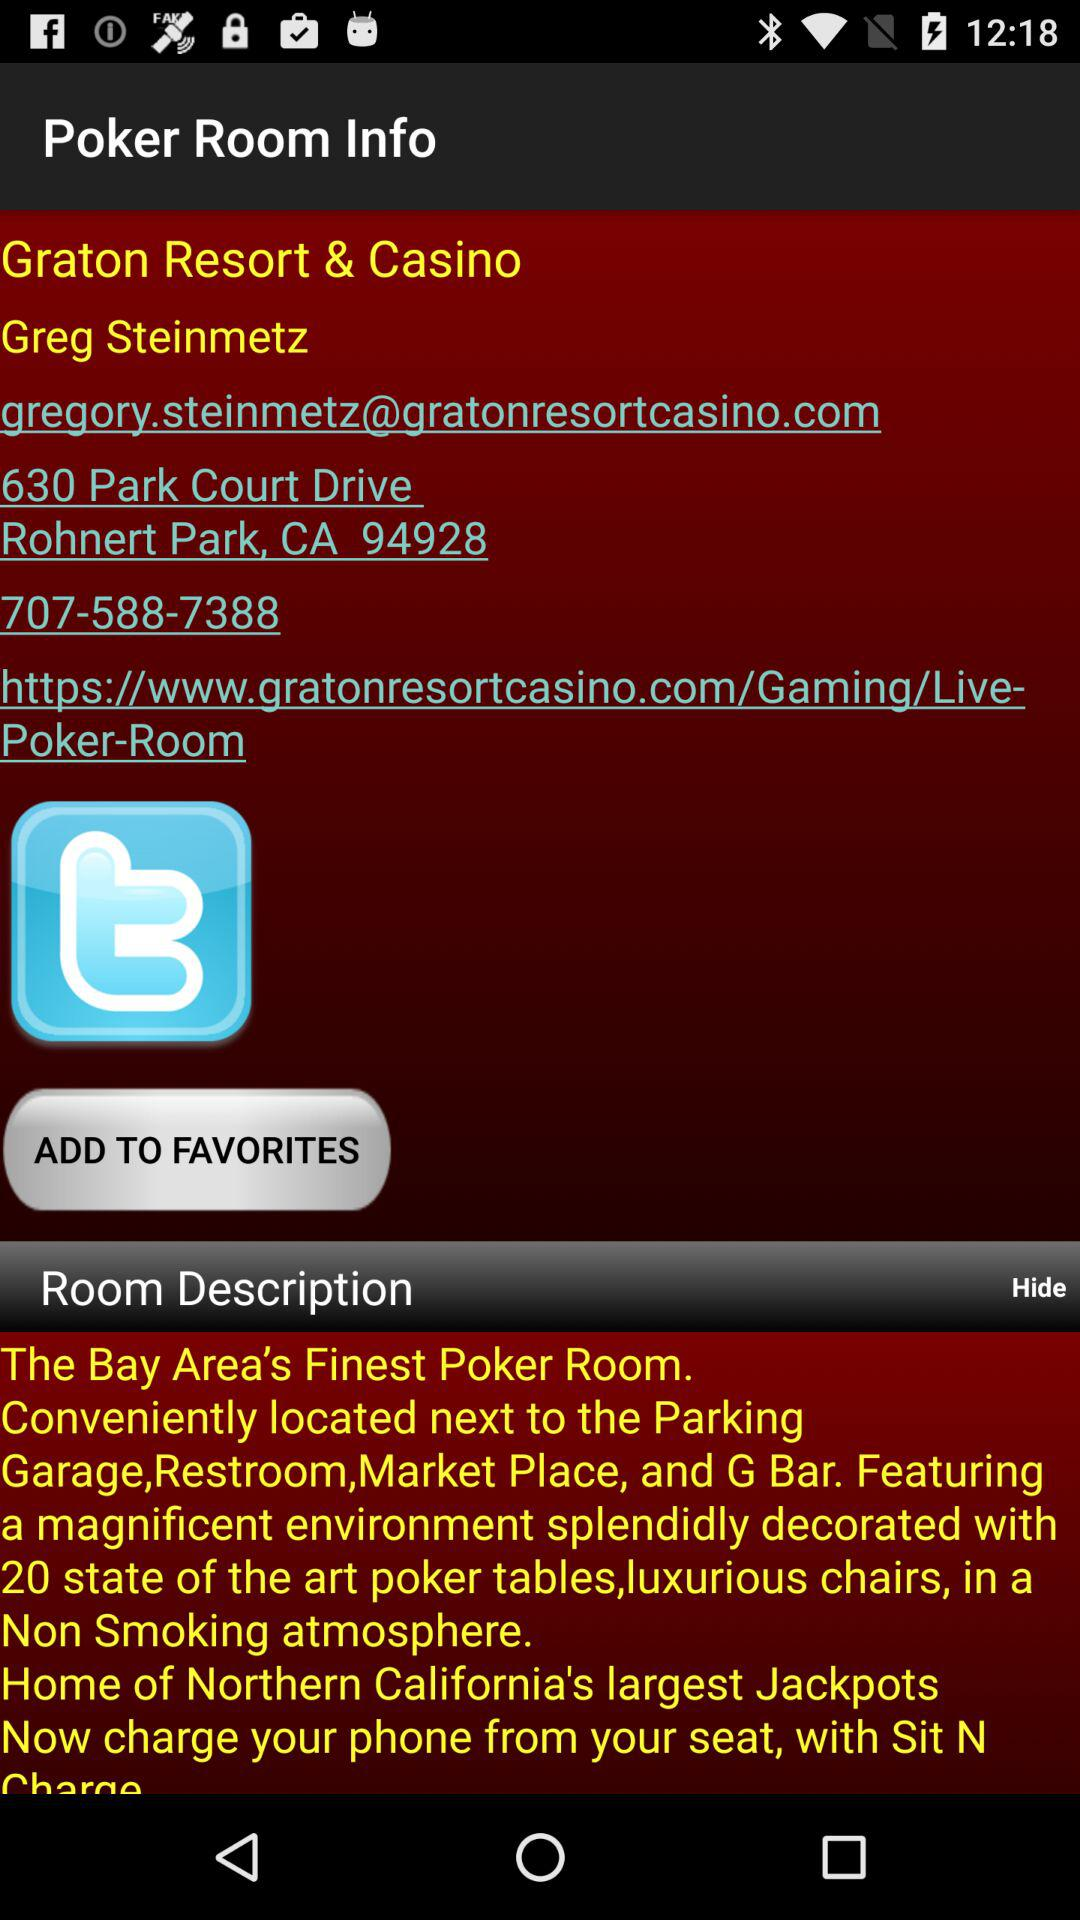What is the address of the "Graton Resort & Casino"? The address of the "Graton Resort & Casino" is 630 Park Court Drive, Rohnert Park, CA 94928. 